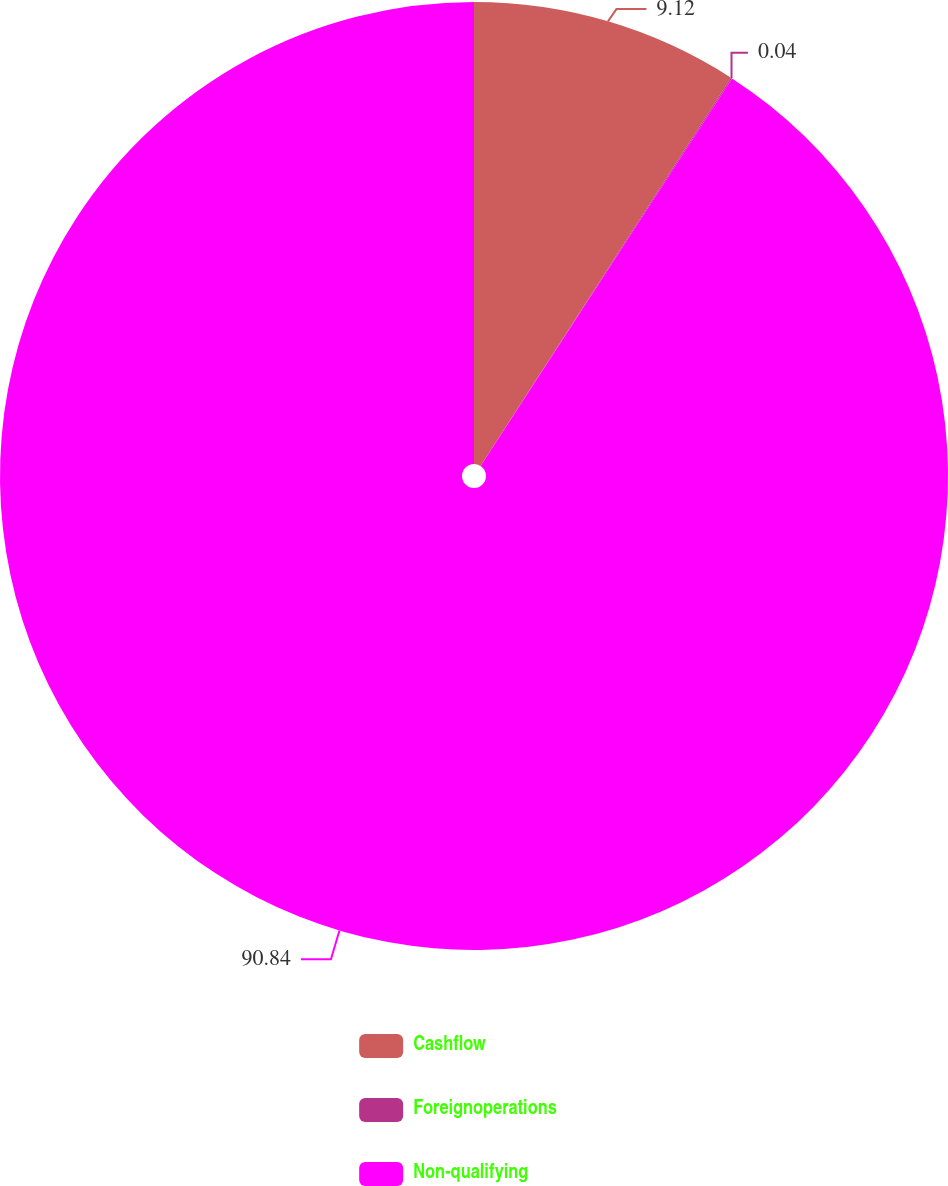Convert chart to OTSL. <chart><loc_0><loc_0><loc_500><loc_500><pie_chart><fcel>Cashflow<fcel>Foreignoperations<fcel>Non-qualifying<nl><fcel>9.12%<fcel>0.04%<fcel>90.83%<nl></chart> 